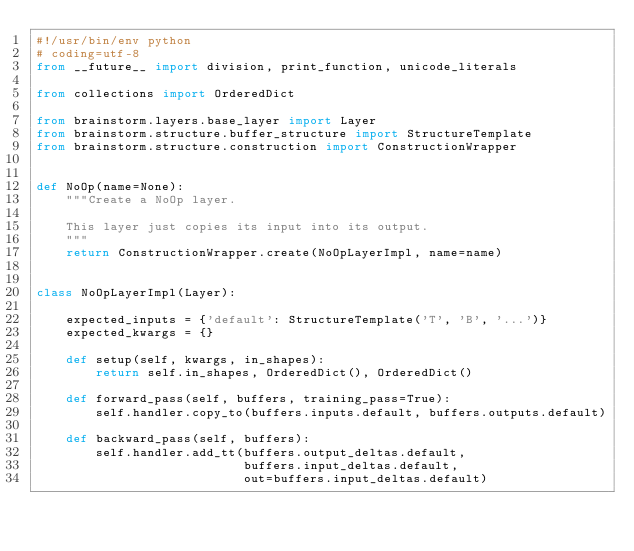<code> <loc_0><loc_0><loc_500><loc_500><_Python_>#!/usr/bin/env python
# coding=utf-8
from __future__ import division, print_function, unicode_literals

from collections import OrderedDict

from brainstorm.layers.base_layer import Layer
from brainstorm.structure.buffer_structure import StructureTemplate
from brainstorm.structure.construction import ConstructionWrapper


def NoOp(name=None):
    """Create a NoOp layer.

    This layer just copies its input into its output.
    """
    return ConstructionWrapper.create(NoOpLayerImpl, name=name)


class NoOpLayerImpl(Layer):

    expected_inputs = {'default': StructureTemplate('T', 'B', '...')}
    expected_kwargs = {}

    def setup(self, kwargs, in_shapes):
        return self.in_shapes, OrderedDict(), OrderedDict()

    def forward_pass(self, buffers, training_pass=True):
        self.handler.copy_to(buffers.inputs.default, buffers.outputs.default)

    def backward_pass(self, buffers):
        self.handler.add_tt(buffers.output_deltas.default,
                            buffers.input_deltas.default,
                            out=buffers.input_deltas.default)
</code> 